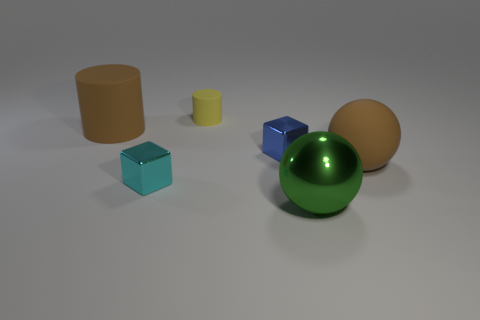Add 2 cylinders. How many objects exist? 8 Subtract 0 red cubes. How many objects are left? 6 Subtract all cubes. How many objects are left? 4 Subtract all tiny blue cubes. Subtract all green balls. How many objects are left? 4 Add 4 big rubber balls. How many big rubber balls are left? 5 Add 4 small matte cylinders. How many small matte cylinders exist? 5 